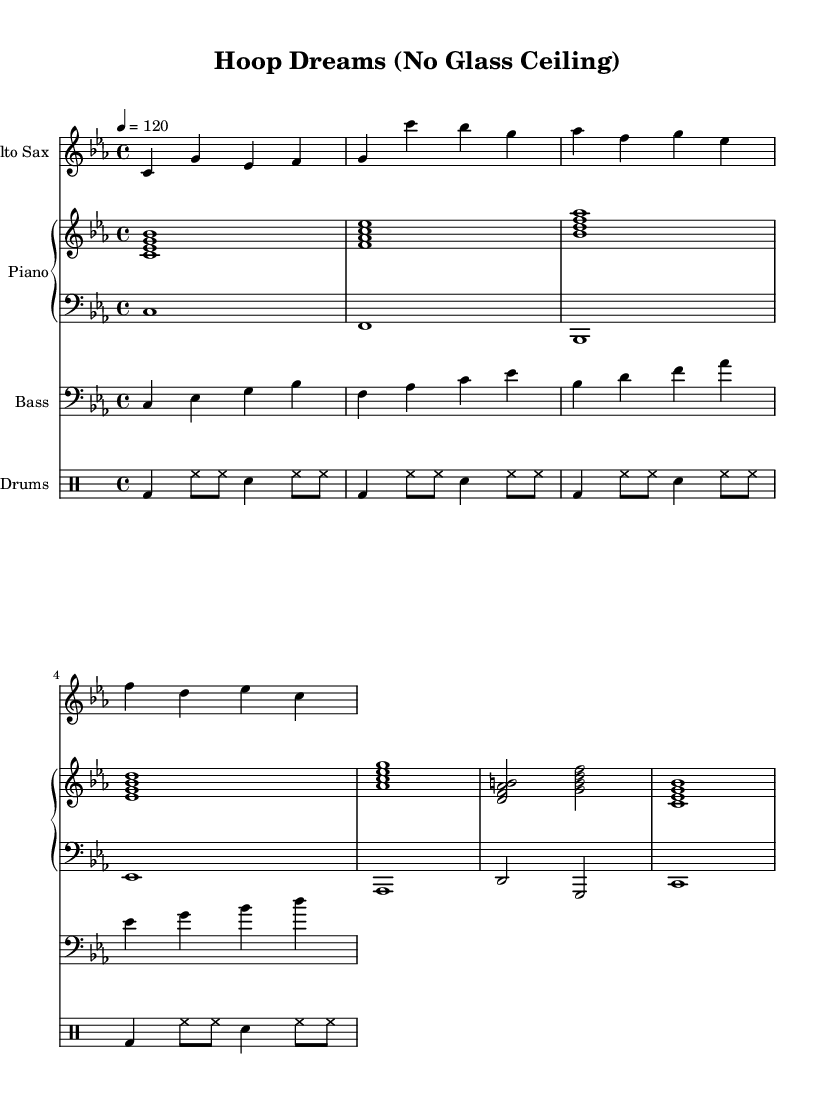What is the key signature of this music? The key signature is C minor, which is indicated by the flat signs on the B and E notes.
Answer: C minor What is the time signature of this piece? The time signature is located at the beginning of the staff and is represented as 4/4, indicating four beats per measure.
Answer: 4/4 What is the tempo marking of this sheet music? The tempo marking indicates the speed of the piece and is noted as 120 beats per minute, which is found after the time signature.
Answer: 120 How many measures are in the alto sax part? By counting each measure in the written part for the alto sax, you can see it has a total of four measures.
Answer: 4 What type of style is this piece intended to represent? The style is suggested as jazz, specifically focusing on funky grooves celebrating female empowerment in sports, as indicated in the title and theme.
Answer: Jazz What instruments are included in this score? The score contains parts for alto sax, piano (both right and left hand), electric bass, and drums, all of which are specified at the beginning.
Answer: Alto Sax, Piano, Electric Bass, Drums How does the drum pattern contribute to the overall feel of the piece? The drum pattern consists of consistent bass drum beats and hi-hat rhythms that drive the groove forward, creating an energetic and upbeat feel, characteristic of funky jazz styles.
Answer: Energetic groove 